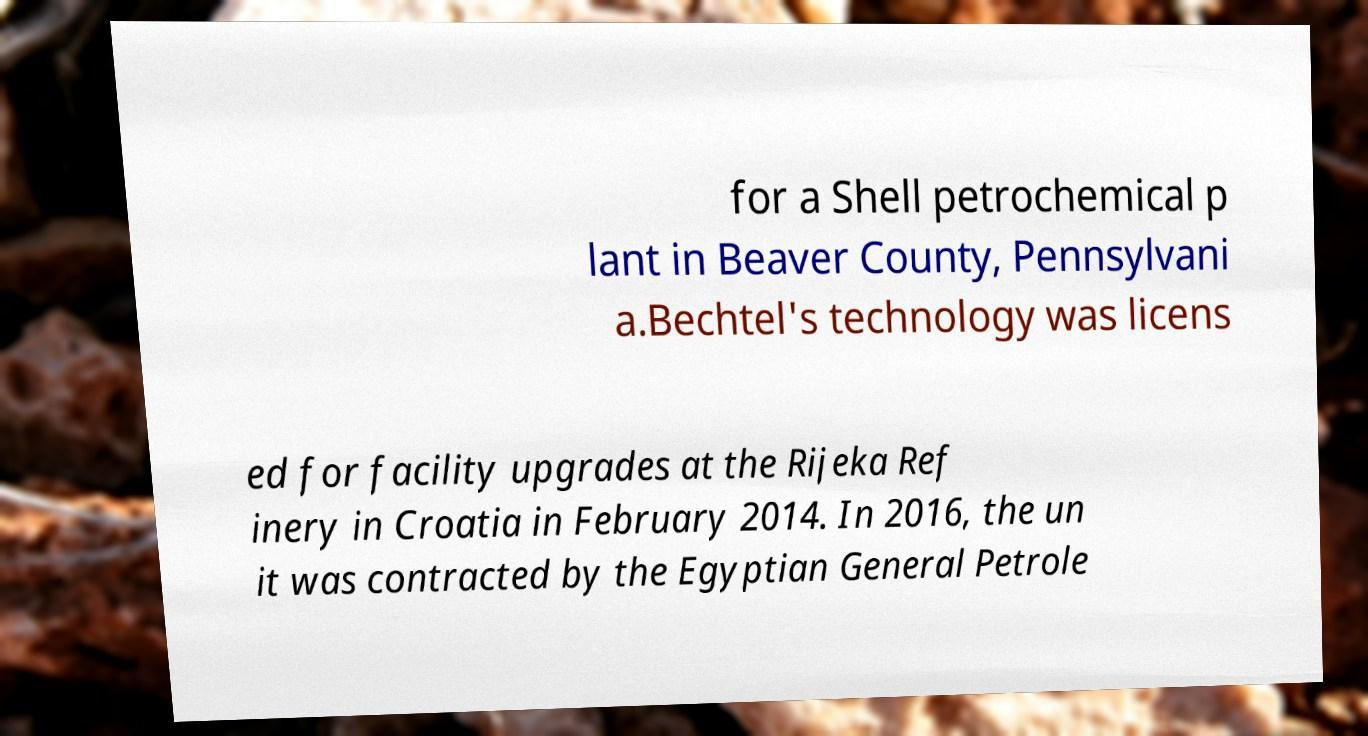Can you accurately transcribe the text from the provided image for me? for a Shell petrochemical p lant in Beaver County, Pennsylvani a.Bechtel's technology was licens ed for facility upgrades at the Rijeka Ref inery in Croatia in February 2014. In 2016, the un it was contracted by the Egyptian General Petrole 